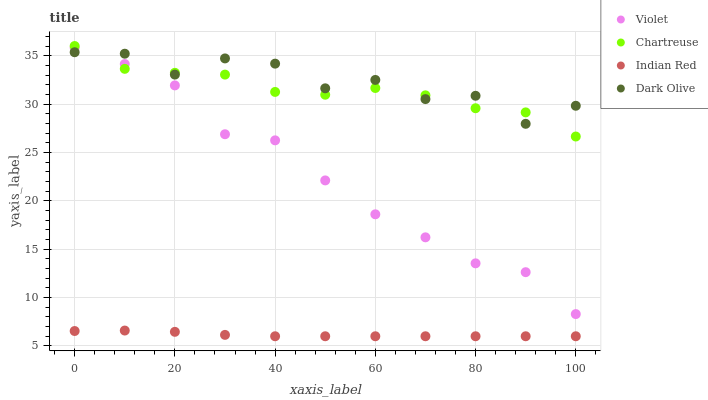Does Indian Red have the minimum area under the curve?
Answer yes or no. Yes. Does Dark Olive have the maximum area under the curve?
Answer yes or no. Yes. Does Dark Olive have the minimum area under the curve?
Answer yes or no. No. Does Indian Red have the maximum area under the curve?
Answer yes or no. No. Is Indian Red the smoothest?
Answer yes or no. Yes. Is Dark Olive the roughest?
Answer yes or no. Yes. Is Dark Olive the smoothest?
Answer yes or no. No. Is Indian Red the roughest?
Answer yes or no. No. Does Indian Red have the lowest value?
Answer yes or no. Yes. Does Dark Olive have the lowest value?
Answer yes or no. No. Does Chartreuse have the highest value?
Answer yes or no. Yes. Does Dark Olive have the highest value?
Answer yes or no. No. Is Indian Red less than Chartreuse?
Answer yes or no. Yes. Is Dark Olive greater than Indian Red?
Answer yes or no. Yes. Does Dark Olive intersect Violet?
Answer yes or no. Yes. Is Dark Olive less than Violet?
Answer yes or no. No. Is Dark Olive greater than Violet?
Answer yes or no. No. Does Indian Red intersect Chartreuse?
Answer yes or no. No. 